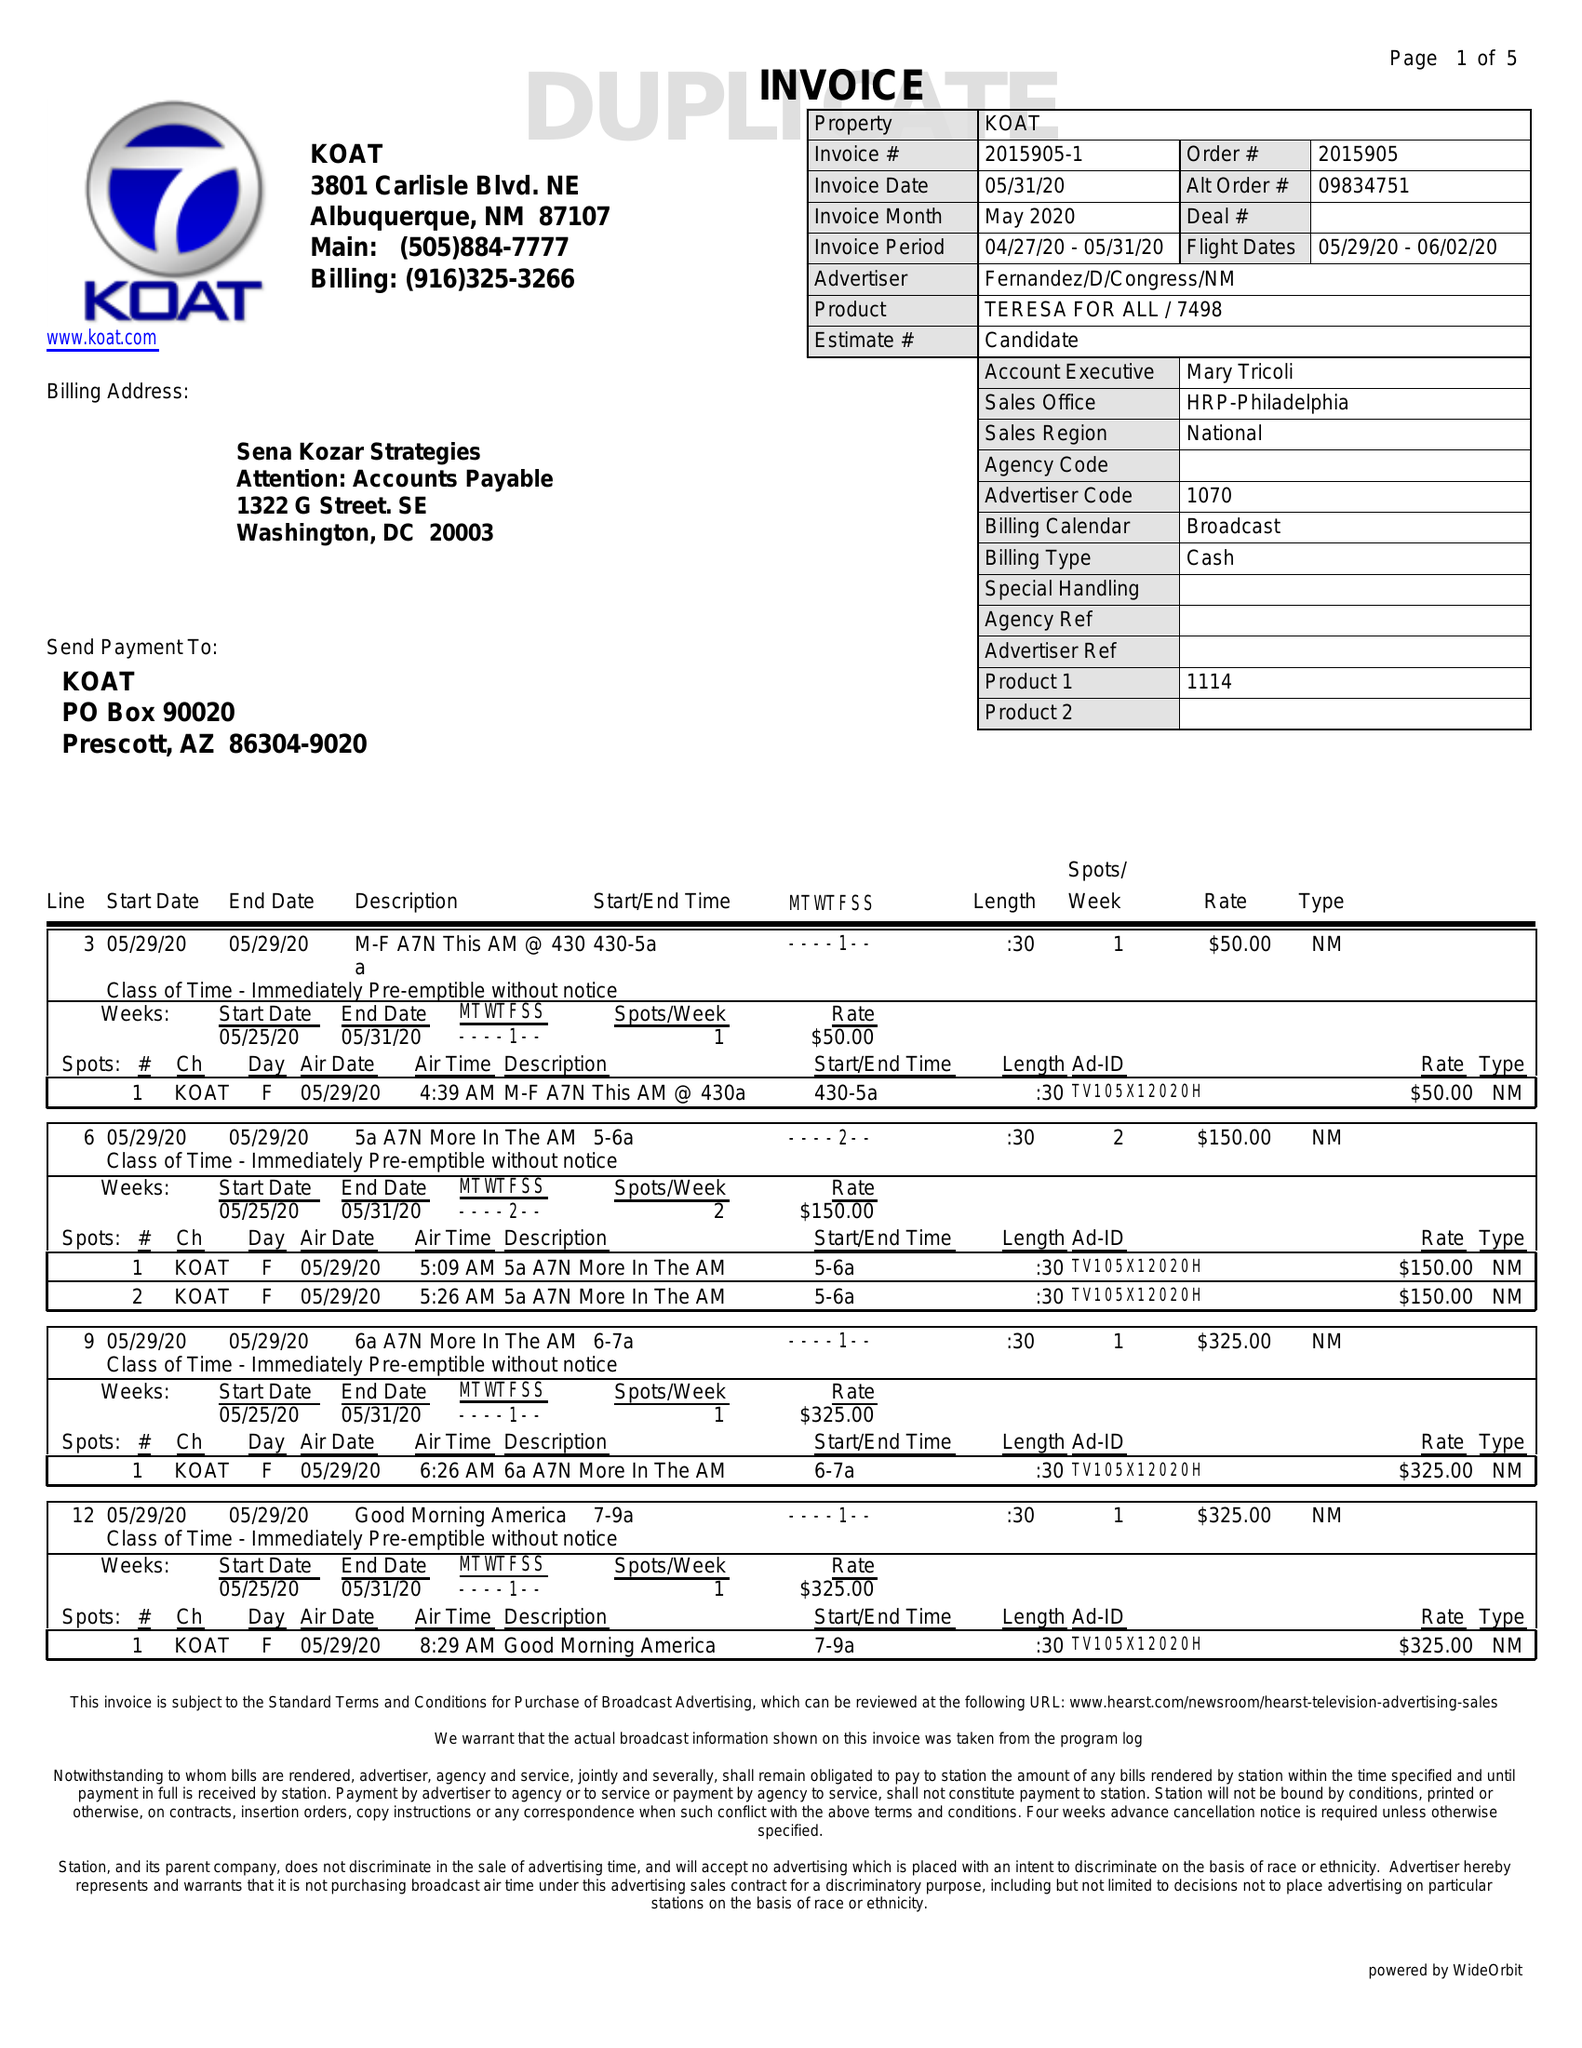What is the value for the contract_num?
Answer the question using a single word or phrase. 2015905 